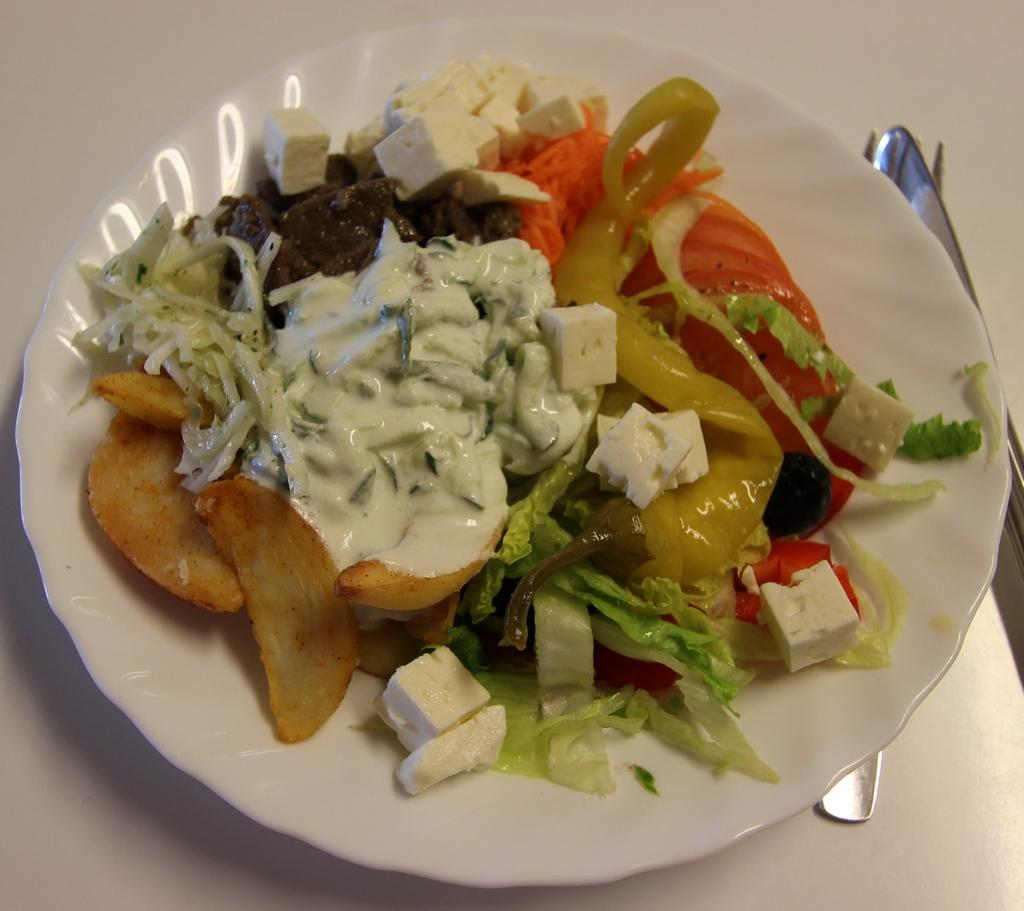What is on the plate in the image? There are food items in the plate. What utensils can be seen in the image? There are forks in the background of the image. What color is the background of the image? The background of the image is white. What type of game is being played in the background of the image? There is no game present in the image; it only shows food items on a plate and forks in the background. 